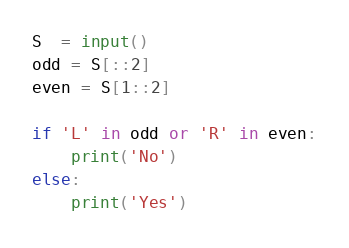<code> <loc_0><loc_0><loc_500><loc_500><_Python_>S  = input()
odd = S[::2]
even = S[1::2]
  
if 'L' in odd or 'R' in even:
    print('No')
else:
    print('Yes')</code> 